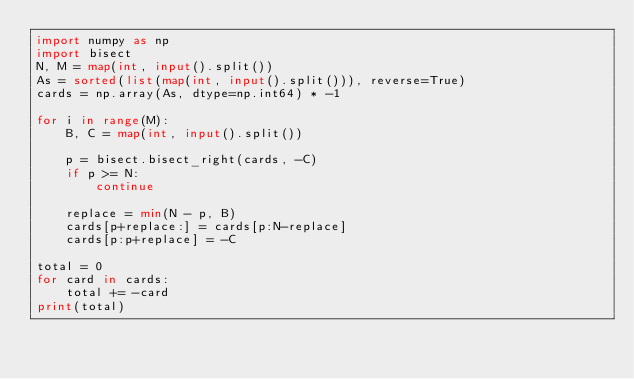Convert code to text. <code><loc_0><loc_0><loc_500><loc_500><_Python_>import numpy as np
import bisect
N, M = map(int, input().split())
As = sorted(list(map(int, input().split())), reverse=True)
cards = np.array(As, dtype=np.int64) * -1

for i in range(M):
    B, C = map(int, input().split())

    p = bisect.bisect_right(cards, -C)
    if p >= N:
        continue

    replace = min(N - p, B)
    cards[p+replace:] = cards[p:N-replace]
    cards[p:p+replace] = -C

total = 0
for card in cards:
    total += -card
print(total)</code> 